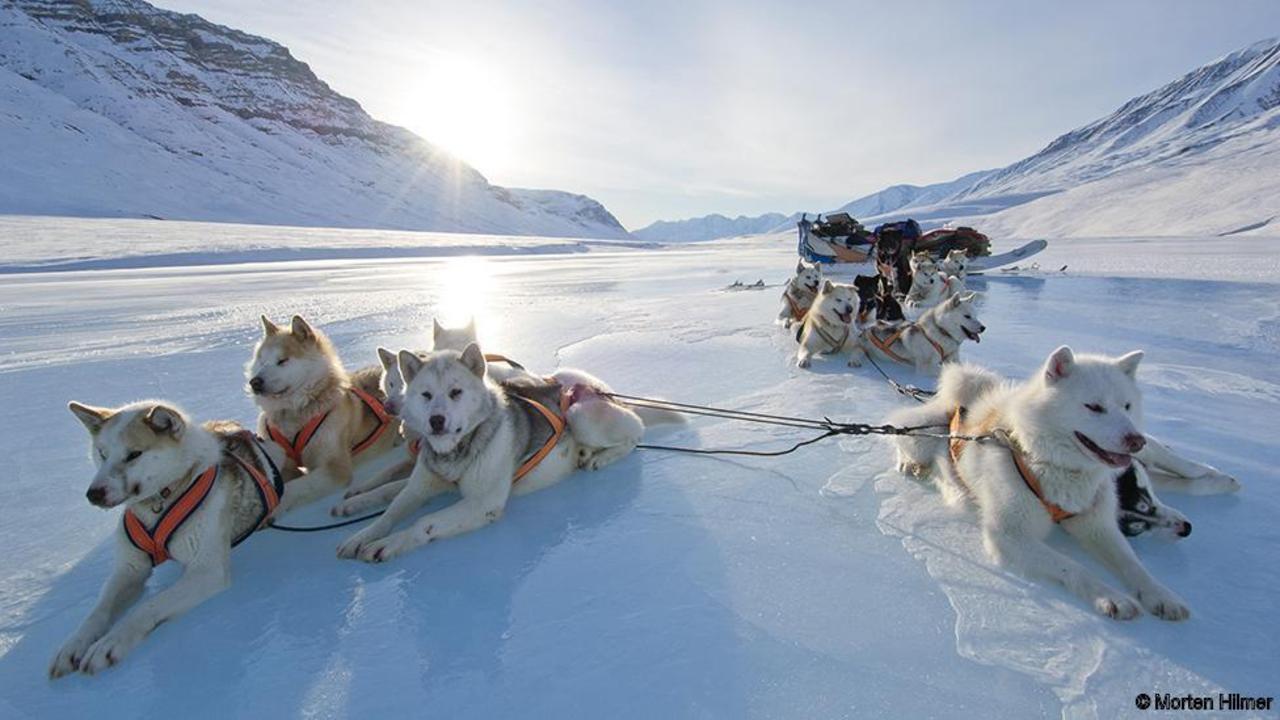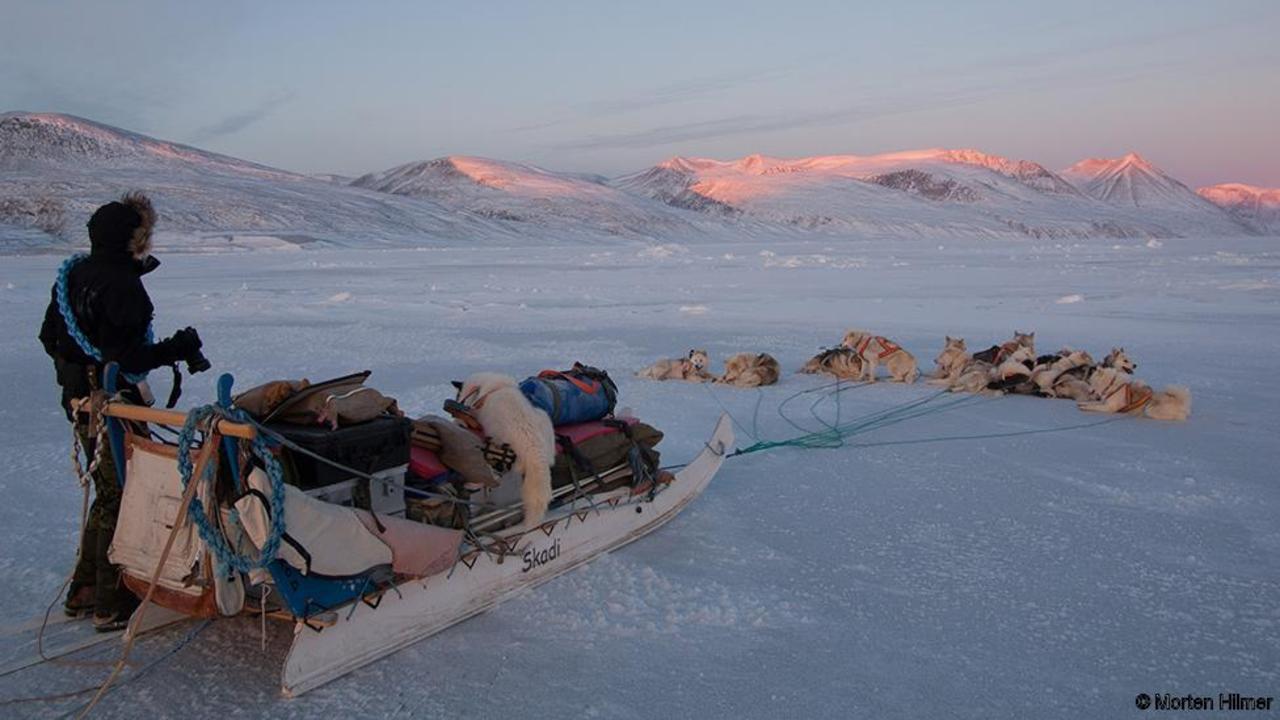The first image is the image on the left, the second image is the image on the right. For the images displayed, is the sentence "There are sled dogs laying in the snow." factually correct? Answer yes or no. Yes. The first image is the image on the left, the second image is the image on the right. Evaluate the accuracy of this statement regarding the images: "Neither image shows a team of animals that are moving across the ground, and both images show sled dog teams.". Is it true? Answer yes or no. Yes. 